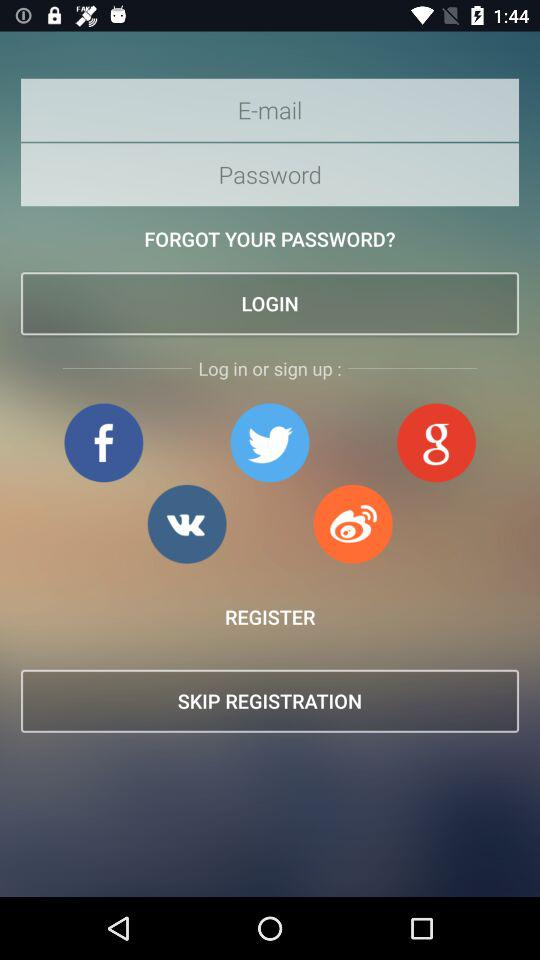What accounts can I use to sign up?
When the provided information is insufficient, respond with <no answer>. <no answer> 